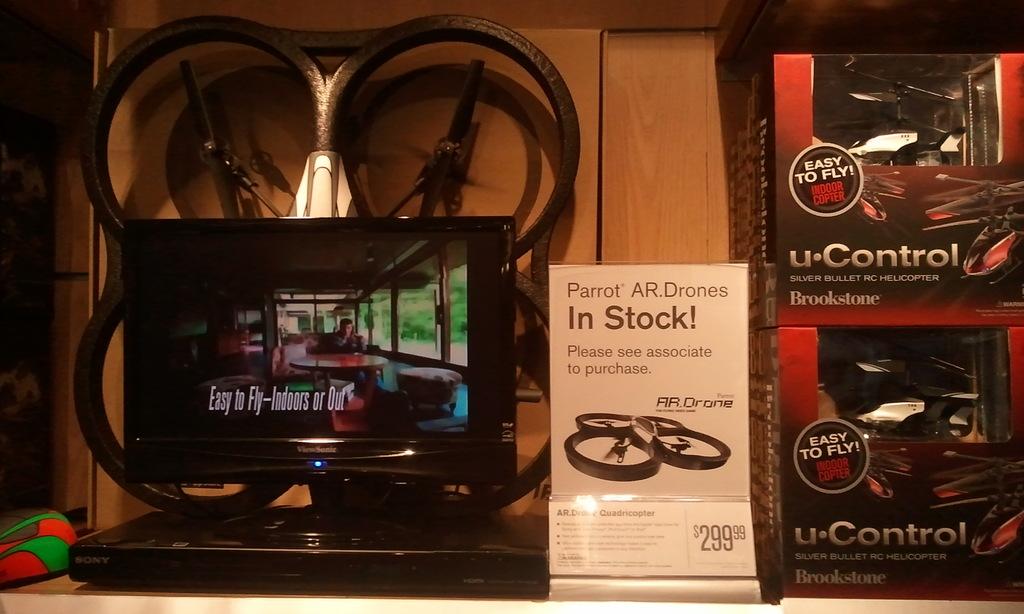Is it in stock?
Your answer should be compact. Yes. What brand it is?
Provide a succinct answer. Parrot. 